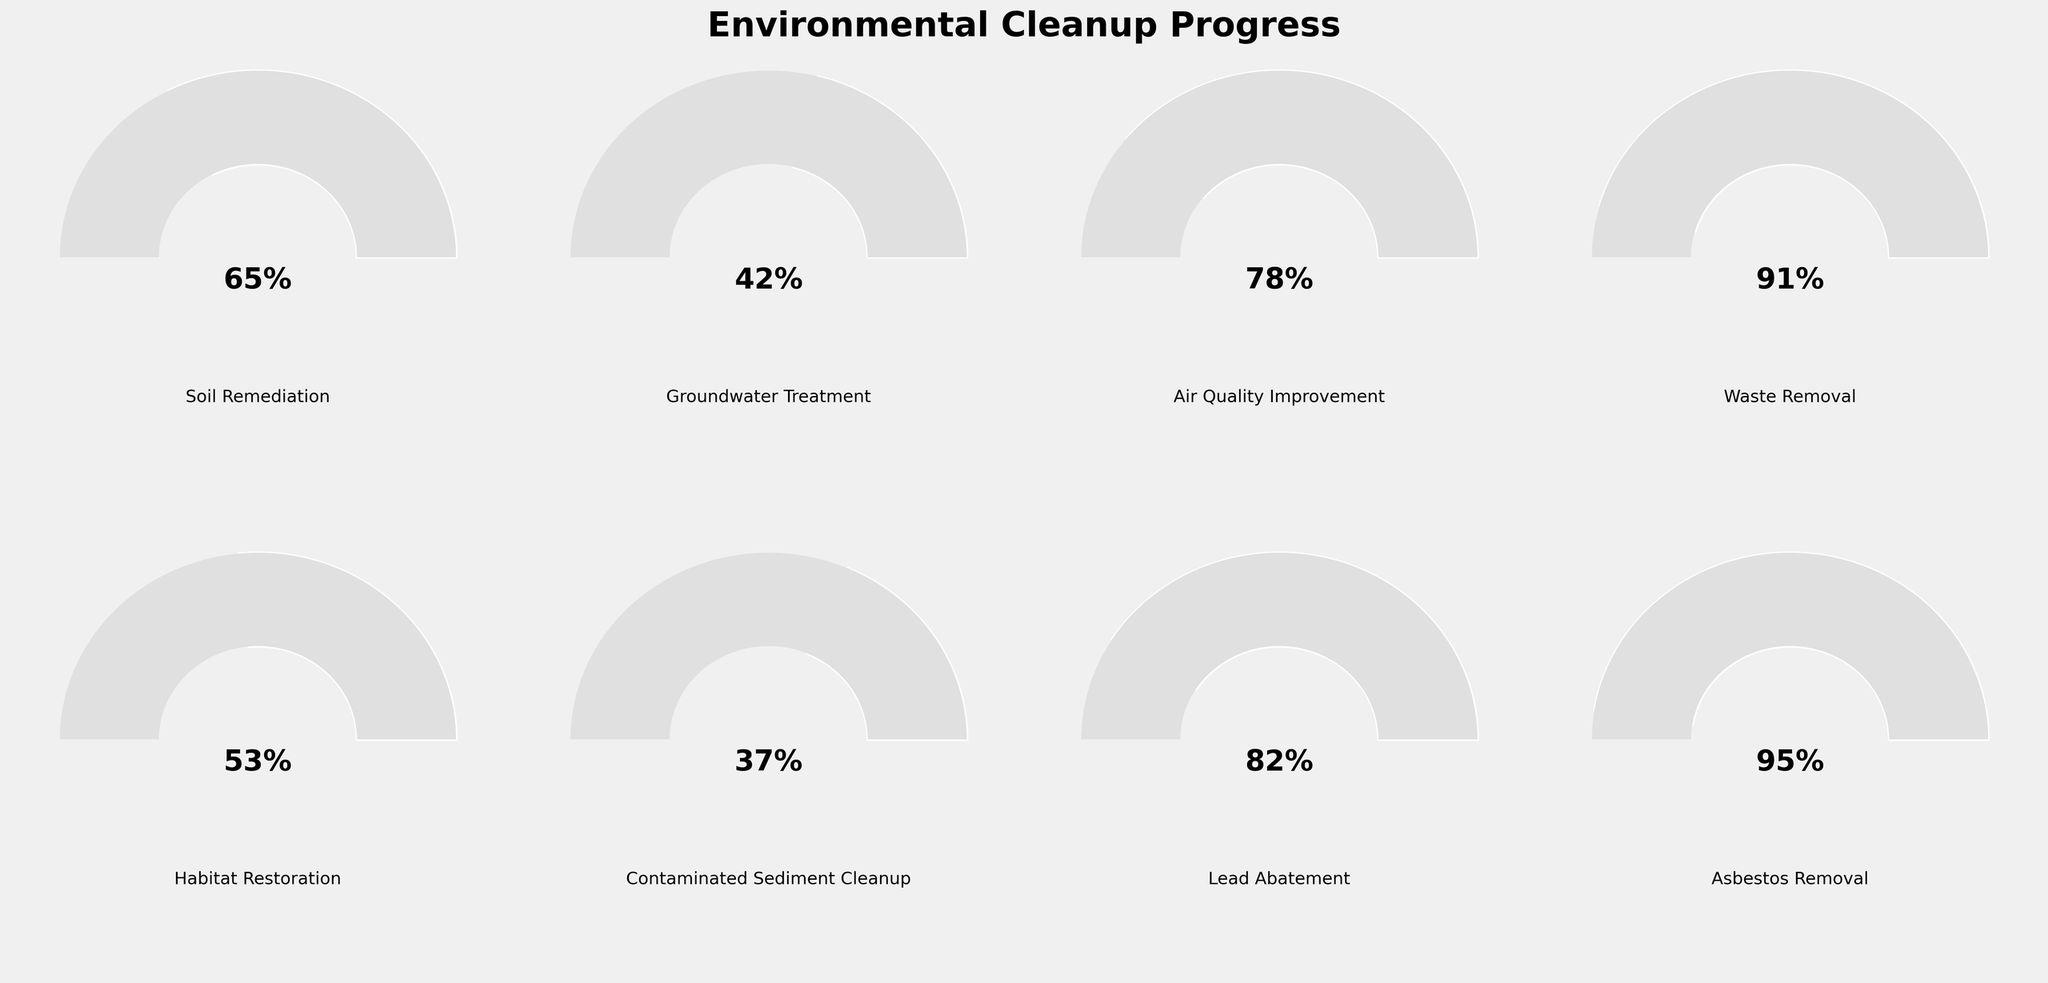What's the highest completion percentage among the categories? The category with the highest completion percentage is determined by comparing all the given percentages. The figure shows 'Asbestos Removal' at 95%, which is the highest percentage.
Answer: 95% Which category has the lowest completion percentage? To find the category with the lowest completion percentage, we compare all the percentages. The figure indicates 'Contaminated Sediment Cleanup' has the lowest percentage at 37%.
Answer: Contaminated Sediment Cleanup How many categories have a completion percentage higher than 80%? We need to identify all categories with percentages above 80%. According to the figure, 'Waste Removal,' 'Lead Abatement,' and 'Asbestos Removal' are above 80%. That makes 3 categories.
Answer: 3 What's the average completion percentage across all categories? To calculate the average, sum all the completion percentages and divide by the number of categories. The percentages are: 65 + 42 + 78 + 91 + 53 + 37 + 82 + 95. This sums to 543. Dividing by 8 (number of categories) gives 67.875.
Answer: 67.875% Which category's cleanup effort needs the most improvement? To identify which category needs the most improvement, look for the one with the lowest completion percentage. 'Contaminated Sediment Cleanup' has the lowest at 37%.
Answer: Contaminated Sediment Cleanup Is the completion percentage of 'Air Quality Improvement' higher than the average completion percentage? The completion percentage of 'Air Quality Improvement' is 78%. The average completion percentage is 67.875%. Since 78% is greater than 67.875%, the answer is yes.
Answer: Yes What's the median completion percentage among the listed categories? To find the median, list the percentages in order: 37, 42, 53, 65, 78, 82, 91, 95. The median of 8 numbers is the average of the 4th and 5th numbers, which are 65 and 78. So, (65 + 78) / 2 = 71.5%.
Answer: 71.5% How many categories have a completion percentage below 50%? Count the categories with completion percentages less than 50%. Those are 'Groundwater Treatment' (42%) and 'Contaminated Sediment Cleanup' (37%). This results in 2 categories.
Answer: 2 Which two categories have their combined completion percentage closest to 100%? To find the closest to 100%, sum combinations of percentages: (65 + 37), (42 + 53), etc. 'Groundwater Treatment' (42%) combined with 'Habitat Restoration' (53%) sums to 95%, closest to 100%.
Answer: Groundwater Treatment and Habitat Restoration 